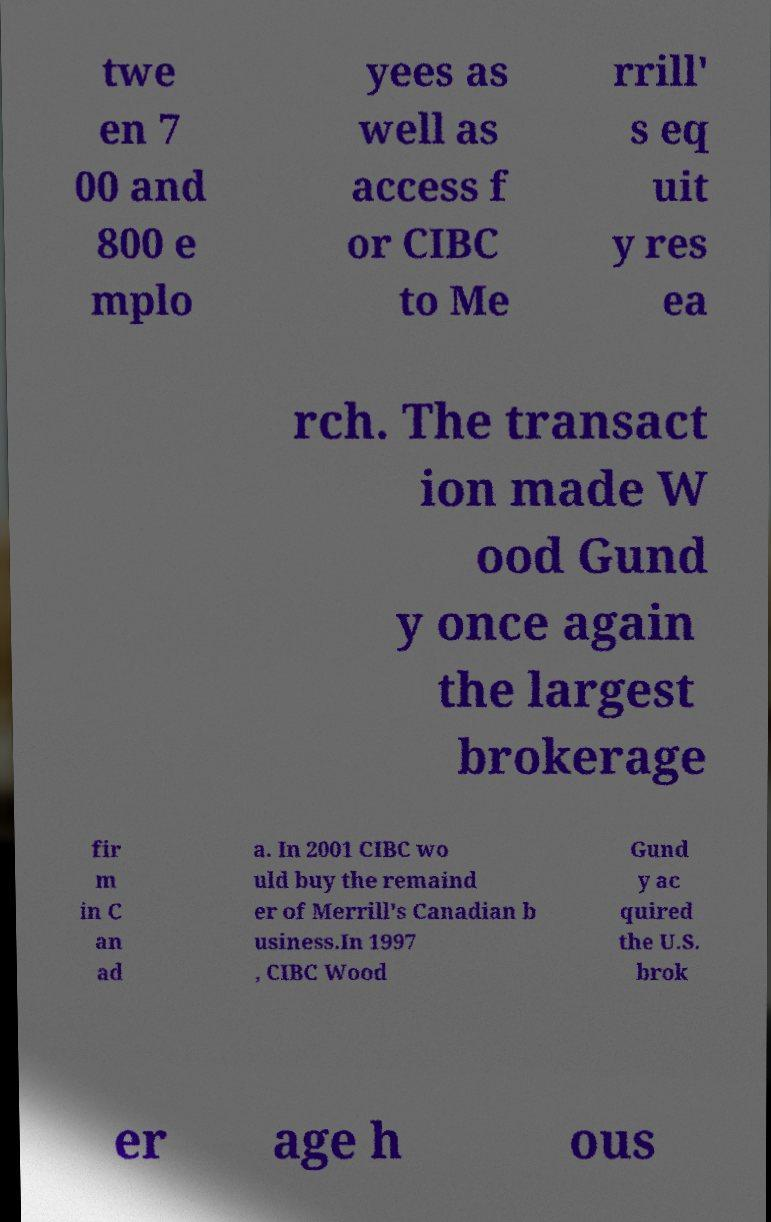What messages or text are displayed in this image? I need them in a readable, typed format. twe en 7 00 and 800 e mplo yees as well as access f or CIBC to Me rrill' s eq uit y res ea rch. The transact ion made W ood Gund y once again the largest brokerage fir m in C an ad a. In 2001 CIBC wo uld buy the remaind er of Merrill's Canadian b usiness.In 1997 , CIBC Wood Gund y ac quired the U.S. brok er age h ous 